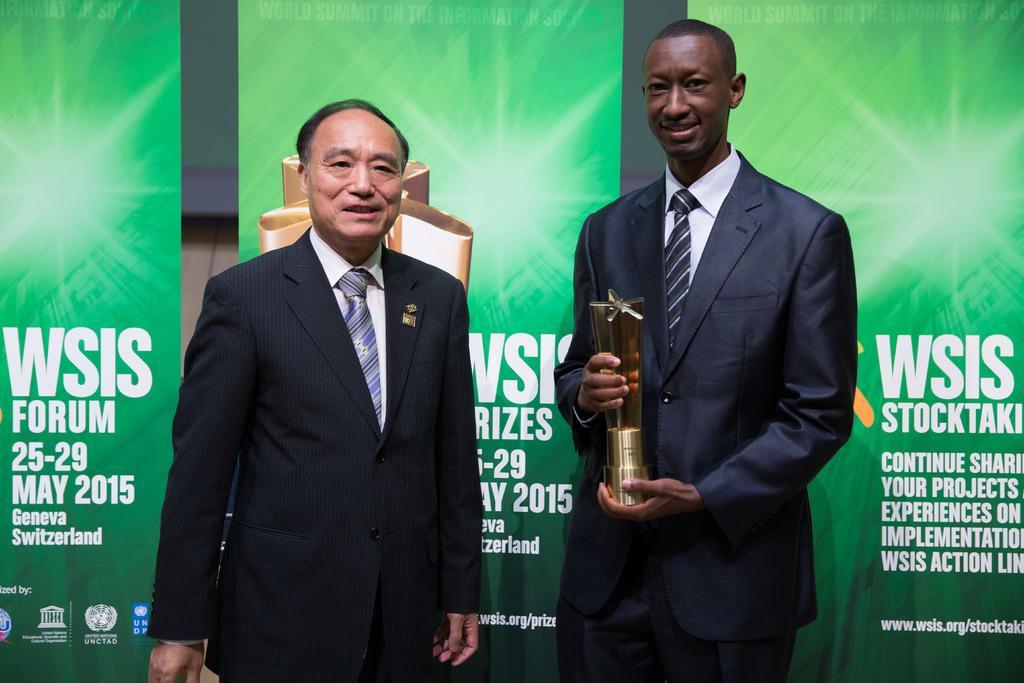Please provide a concise description of this image. In the picture I can see two men are standing and smiling. The man on the right side is holding an object in hands. In the background I can see banners on which there is something written on them. These people are wearing suits. 